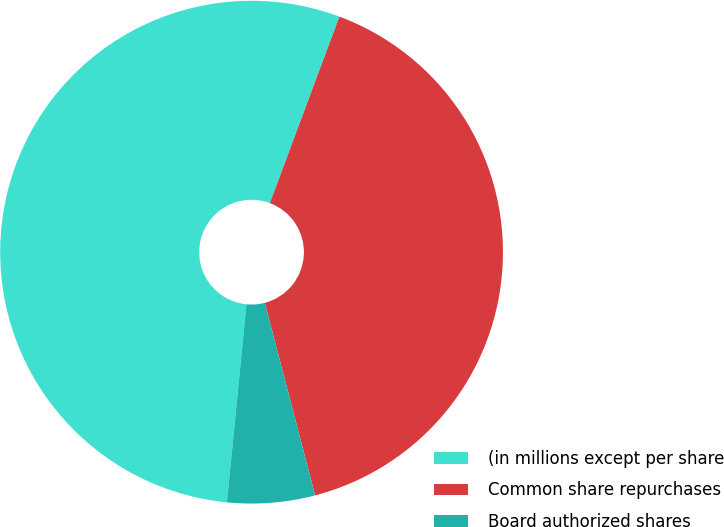Convert chart. <chart><loc_0><loc_0><loc_500><loc_500><pie_chart><fcel>(in millions except per share<fcel>Common share repurchases<fcel>Board authorized shares<nl><fcel>54.12%<fcel>40.25%<fcel>5.63%<nl></chart> 